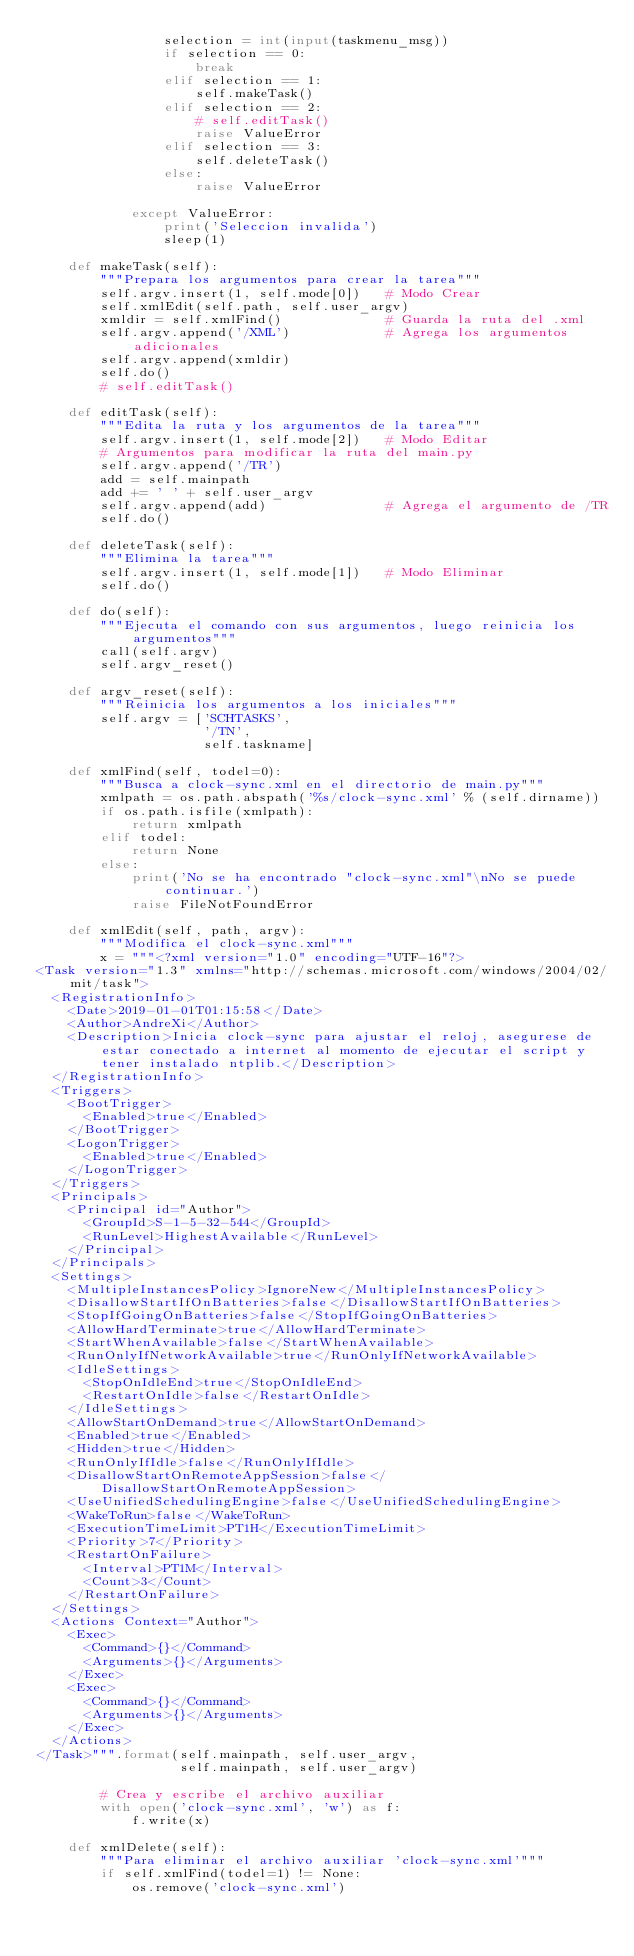Convert code to text. <code><loc_0><loc_0><loc_500><loc_500><_Python_>                selection = int(input(taskmenu_msg))
                if selection == 0:
                    break
                elif selection == 1:
                    self.makeTask()
                elif selection == 2:
                    # self.editTask()
                    raise ValueError
                elif selection == 3:
                    self.deleteTask()
                else:
                    raise ValueError

            except ValueError:
                print('Seleccion invalida')
                sleep(1)

    def makeTask(self):
        """Prepara los argumentos para crear la tarea"""
        self.argv.insert(1, self.mode[0])   # Modo Crear
        self.xmlEdit(self.path, self.user_argv)
        xmldir = self.xmlFind()             # Guarda la ruta del .xml
        self.argv.append('/XML')            # Agrega los argumentos adicionales
        self.argv.append(xmldir)
        self.do()
        # self.editTask()

    def editTask(self):
        """Edita la ruta y los argumentos de la tarea"""
        self.argv.insert(1, self.mode[2])   # Modo Editar
        # Argumentos para modificar la ruta del main.py
        self.argv.append('/TR')
        add = self.mainpath
        add += ' ' + self.user_argv
        self.argv.append(add)               # Agrega el argumento de /TR
        self.do()

    def deleteTask(self):
        """Elimina la tarea"""
        self.argv.insert(1, self.mode[1])   # Modo Eliminar
        self.do()

    def do(self):
        """Ejecuta el comando con sus argumentos, luego reinicia los argumentos"""
        call(self.argv)
        self.argv_reset()

    def argv_reset(self):
        """Reinicia los argumentos a los iniciales"""
        self.argv = ['SCHTASKS',
                     '/TN',
                     self.taskname]

    def xmlFind(self, todel=0):
        """Busca a clock-sync.xml en el directorio de main.py"""
        xmlpath = os.path.abspath('%s/clock-sync.xml' % (self.dirname))
        if os.path.isfile(xmlpath):
            return xmlpath
        elif todel:
            return None
        else:
            print('No se ha encontrado "clock-sync.xml"\nNo se puede continuar.')
            raise FileNotFoundError

    def xmlEdit(self, path, argv):
        """Modifica el clock-sync.xml"""
        x = """<?xml version="1.0" encoding="UTF-16"?>
<Task version="1.3" xmlns="http://schemas.microsoft.com/windows/2004/02/mit/task">
  <RegistrationInfo>
    <Date>2019-01-01T01:15:58</Date>
    <Author>AndreXi</Author>
    <Description>Inicia clock-sync para ajustar el reloj, asegurese de estar conectado a internet al momento de ejecutar el script y tener instalado ntplib.</Description>
  </RegistrationInfo>
  <Triggers>
    <BootTrigger>
      <Enabled>true</Enabled>
    </BootTrigger>
    <LogonTrigger>
      <Enabled>true</Enabled>
    </LogonTrigger>
  </Triggers>
  <Principals>
    <Principal id="Author">
      <GroupId>S-1-5-32-544</GroupId>
      <RunLevel>HighestAvailable</RunLevel>
    </Principal>
  </Principals>
  <Settings>
    <MultipleInstancesPolicy>IgnoreNew</MultipleInstancesPolicy>
    <DisallowStartIfOnBatteries>false</DisallowStartIfOnBatteries>
    <StopIfGoingOnBatteries>false</StopIfGoingOnBatteries>
    <AllowHardTerminate>true</AllowHardTerminate>
    <StartWhenAvailable>false</StartWhenAvailable>
    <RunOnlyIfNetworkAvailable>true</RunOnlyIfNetworkAvailable>
    <IdleSettings>
      <StopOnIdleEnd>true</StopOnIdleEnd>
      <RestartOnIdle>false</RestartOnIdle>
    </IdleSettings>
    <AllowStartOnDemand>true</AllowStartOnDemand>
    <Enabled>true</Enabled>
    <Hidden>true</Hidden>
    <RunOnlyIfIdle>false</RunOnlyIfIdle>
    <DisallowStartOnRemoteAppSession>false</DisallowStartOnRemoteAppSession>
    <UseUnifiedSchedulingEngine>false</UseUnifiedSchedulingEngine>
    <WakeToRun>false</WakeToRun>
    <ExecutionTimeLimit>PT1H</ExecutionTimeLimit>
    <Priority>7</Priority>
    <RestartOnFailure>
      <Interval>PT1M</Interval>
      <Count>3</Count>
    </RestartOnFailure>
  </Settings>
  <Actions Context="Author">
    <Exec>
      <Command>{}</Command>
      <Arguments>{}</Arguments>
    </Exec>
    <Exec>
      <Command>{}</Command>
      <Arguments>{}</Arguments>
    </Exec>
  </Actions>
</Task>""".format(self.mainpath, self.user_argv,
                  self.mainpath, self.user_argv)

        # Crea y escribe el archivo auxiliar
        with open('clock-sync.xml', 'w') as f:
            f.write(x)

    def xmlDelete(self):
        """Para eliminar el archivo auxiliar 'clock-sync.xml'"""
        if self.xmlFind(todel=1) != None:
            os.remove('clock-sync.xml')
</code> 